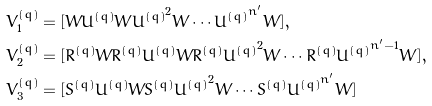<formula> <loc_0><loc_0><loc_500><loc_500>& V ^ { ( q ) } _ { 1 } = [ W U ^ { ( q ) } W { U ^ { ( q ) } } ^ { 2 } W \cdots { U ^ { ( q ) } } ^ { n ^ { \prime } } W ] , \\ & V ^ { ( q ) } _ { 2 } = [ R ^ { ( q ) } W R ^ { ( q ) } U ^ { ( q ) } W R ^ { ( q ) } { U ^ { ( q ) } } ^ { 2 } W \cdots R ^ { ( q ) } { U ^ { ( q ) } } ^ { n ^ { \prime } - 1 } W ] , \\ & V ^ { ( q ) } _ { 3 } = [ S ^ { ( q ) } { U ^ { ( q ) } } W S ^ { ( q ) } { U ^ { ( q ) } } ^ { 2 } W \cdots S ^ { ( q ) } { U ^ { ( q ) } } ^ { n ^ { \prime } } W ]</formula> 